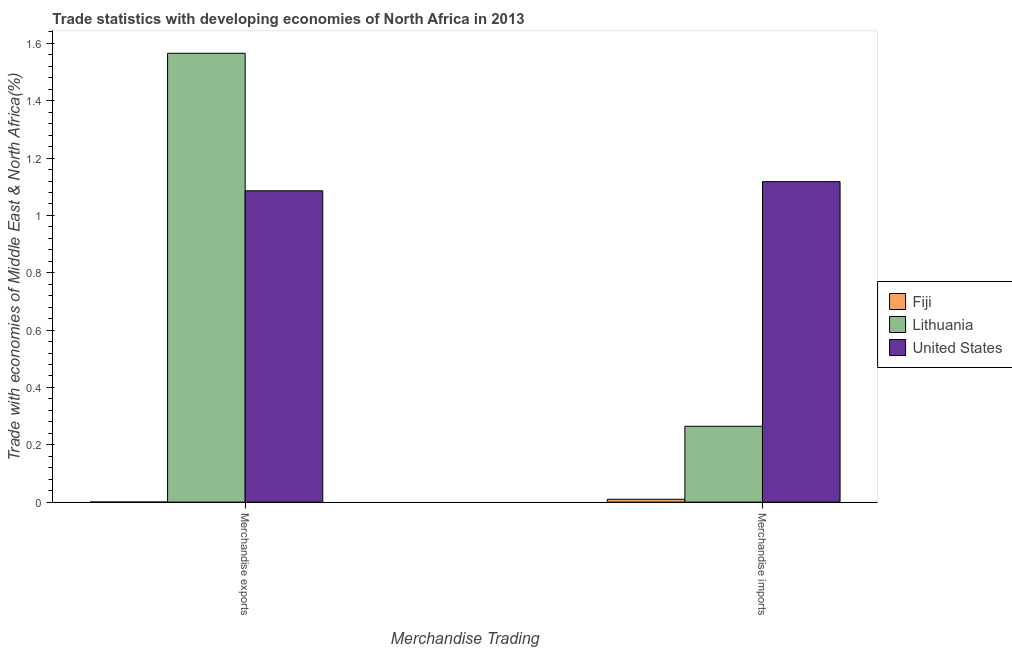Are the number of bars per tick equal to the number of legend labels?
Offer a terse response. Yes. Are the number of bars on each tick of the X-axis equal?
Offer a terse response. Yes. How many bars are there on the 1st tick from the right?
Give a very brief answer. 3. What is the label of the 2nd group of bars from the left?
Your response must be concise. Merchandise imports. What is the merchandise exports in Lithuania?
Offer a terse response. 1.57. Across all countries, what is the maximum merchandise exports?
Offer a very short reply. 1.57. Across all countries, what is the minimum merchandise imports?
Your answer should be very brief. 0.01. In which country was the merchandise imports maximum?
Provide a succinct answer. United States. In which country was the merchandise exports minimum?
Your answer should be compact. Fiji. What is the total merchandise exports in the graph?
Offer a terse response. 2.65. What is the difference between the merchandise exports in United States and that in Fiji?
Provide a succinct answer. 1.09. What is the difference between the merchandise imports in Fiji and the merchandise exports in United States?
Provide a short and direct response. -1.08. What is the average merchandise exports per country?
Offer a terse response. 0.88. What is the difference between the merchandise exports and merchandise imports in Lithuania?
Your answer should be compact. 1.3. In how many countries, is the merchandise exports greater than 0.16 %?
Keep it short and to the point. 2. What is the ratio of the merchandise imports in Lithuania to that in Fiji?
Your answer should be very brief. 26.67. What does the 2nd bar from the left in Merchandise exports represents?
Make the answer very short. Lithuania. What does the 3rd bar from the right in Merchandise imports represents?
Give a very brief answer. Fiji. How many bars are there?
Your answer should be compact. 6. How many countries are there in the graph?
Offer a very short reply. 3. What is the difference between two consecutive major ticks on the Y-axis?
Provide a succinct answer. 0.2. Are the values on the major ticks of Y-axis written in scientific E-notation?
Offer a very short reply. No. Does the graph contain any zero values?
Your answer should be very brief. No. How are the legend labels stacked?
Make the answer very short. Vertical. What is the title of the graph?
Give a very brief answer. Trade statistics with developing economies of North Africa in 2013. What is the label or title of the X-axis?
Offer a terse response. Merchandise Trading. What is the label or title of the Y-axis?
Make the answer very short. Trade with economies of Middle East & North Africa(%). What is the Trade with economies of Middle East & North Africa(%) of Fiji in Merchandise exports?
Provide a succinct answer. 0. What is the Trade with economies of Middle East & North Africa(%) of Lithuania in Merchandise exports?
Your answer should be compact. 1.57. What is the Trade with economies of Middle East & North Africa(%) in United States in Merchandise exports?
Provide a succinct answer. 1.09. What is the Trade with economies of Middle East & North Africa(%) of Fiji in Merchandise imports?
Ensure brevity in your answer.  0.01. What is the Trade with economies of Middle East & North Africa(%) in Lithuania in Merchandise imports?
Keep it short and to the point. 0.26. What is the Trade with economies of Middle East & North Africa(%) of United States in Merchandise imports?
Give a very brief answer. 1.12. Across all Merchandise Trading, what is the maximum Trade with economies of Middle East & North Africa(%) in Fiji?
Your response must be concise. 0.01. Across all Merchandise Trading, what is the maximum Trade with economies of Middle East & North Africa(%) in Lithuania?
Make the answer very short. 1.57. Across all Merchandise Trading, what is the maximum Trade with economies of Middle East & North Africa(%) in United States?
Give a very brief answer. 1.12. Across all Merchandise Trading, what is the minimum Trade with economies of Middle East & North Africa(%) in Fiji?
Make the answer very short. 0. Across all Merchandise Trading, what is the minimum Trade with economies of Middle East & North Africa(%) in Lithuania?
Your response must be concise. 0.26. Across all Merchandise Trading, what is the minimum Trade with economies of Middle East & North Africa(%) in United States?
Your answer should be very brief. 1.09. What is the total Trade with economies of Middle East & North Africa(%) in Fiji in the graph?
Provide a succinct answer. 0.01. What is the total Trade with economies of Middle East & North Africa(%) in Lithuania in the graph?
Provide a succinct answer. 1.83. What is the total Trade with economies of Middle East & North Africa(%) in United States in the graph?
Make the answer very short. 2.2. What is the difference between the Trade with economies of Middle East & North Africa(%) in Fiji in Merchandise exports and that in Merchandise imports?
Offer a very short reply. -0.01. What is the difference between the Trade with economies of Middle East & North Africa(%) of Lithuania in Merchandise exports and that in Merchandise imports?
Offer a very short reply. 1.3. What is the difference between the Trade with economies of Middle East & North Africa(%) in United States in Merchandise exports and that in Merchandise imports?
Give a very brief answer. -0.03. What is the difference between the Trade with economies of Middle East & North Africa(%) in Fiji in Merchandise exports and the Trade with economies of Middle East & North Africa(%) in Lithuania in Merchandise imports?
Your answer should be compact. -0.26. What is the difference between the Trade with economies of Middle East & North Africa(%) of Fiji in Merchandise exports and the Trade with economies of Middle East & North Africa(%) of United States in Merchandise imports?
Your answer should be compact. -1.12. What is the difference between the Trade with economies of Middle East & North Africa(%) in Lithuania in Merchandise exports and the Trade with economies of Middle East & North Africa(%) in United States in Merchandise imports?
Keep it short and to the point. 0.45. What is the average Trade with economies of Middle East & North Africa(%) in Fiji per Merchandise Trading?
Your answer should be compact. 0.01. What is the average Trade with economies of Middle East & North Africa(%) of Lithuania per Merchandise Trading?
Your answer should be compact. 0.92. What is the average Trade with economies of Middle East & North Africa(%) in United States per Merchandise Trading?
Provide a succinct answer. 1.1. What is the difference between the Trade with economies of Middle East & North Africa(%) of Fiji and Trade with economies of Middle East & North Africa(%) of Lithuania in Merchandise exports?
Your answer should be compact. -1.57. What is the difference between the Trade with economies of Middle East & North Africa(%) in Fiji and Trade with economies of Middle East & North Africa(%) in United States in Merchandise exports?
Give a very brief answer. -1.09. What is the difference between the Trade with economies of Middle East & North Africa(%) of Lithuania and Trade with economies of Middle East & North Africa(%) of United States in Merchandise exports?
Keep it short and to the point. 0.48. What is the difference between the Trade with economies of Middle East & North Africa(%) of Fiji and Trade with economies of Middle East & North Africa(%) of Lithuania in Merchandise imports?
Your answer should be compact. -0.25. What is the difference between the Trade with economies of Middle East & North Africa(%) of Fiji and Trade with economies of Middle East & North Africa(%) of United States in Merchandise imports?
Your response must be concise. -1.11. What is the difference between the Trade with economies of Middle East & North Africa(%) of Lithuania and Trade with economies of Middle East & North Africa(%) of United States in Merchandise imports?
Offer a very short reply. -0.85. What is the ratio of the Trade with economies of Middle East & North Africa(%) of Fiji in Merchandise exports to that in Merchandise imports?
Offer a terse response. 0.01. What is the ratio of the Trade with economies of Middle East & North Africa(%) in Lithuania in Merchandise exports to that in Merchandise imports?
Provide a short and direct response. 5.92. What is the ratio of the Trade with economies of Middle East & North Africa(%) in United States in Merchandise exports to that in Merchandise imports?
Offer a very short reply. 0.97. What is the difference between the highest and the second highest Trade with economies of Middle East & North Africa(%) of Fiji?
Keep it short and to the point. 0.01. What is the difference between the highest and the second highest Trade with economies of Middle East & North Africa(%) of Lithuania?
Offer a very short reply. 1.3. What is the difference between the highest and the second highest Trade with economies of Middle East & North Africa(%) in United States?
Offer a terse response. 0.03. What is the difference between the highest and the lowest Trade with economies of Middle East & North Africa(%) of Fiji?
Your response must be concise. 0.01. What is the difference between the highest and the lowest Trade with economies of Middle East & North Africa(%) of Lithuania?
Keep it short and to the point. 1.3. What is the difference between the highest and the lowest Trade with economies of Middle East & North Africa(%) of United States?
Make the answer very short. 0.03. 